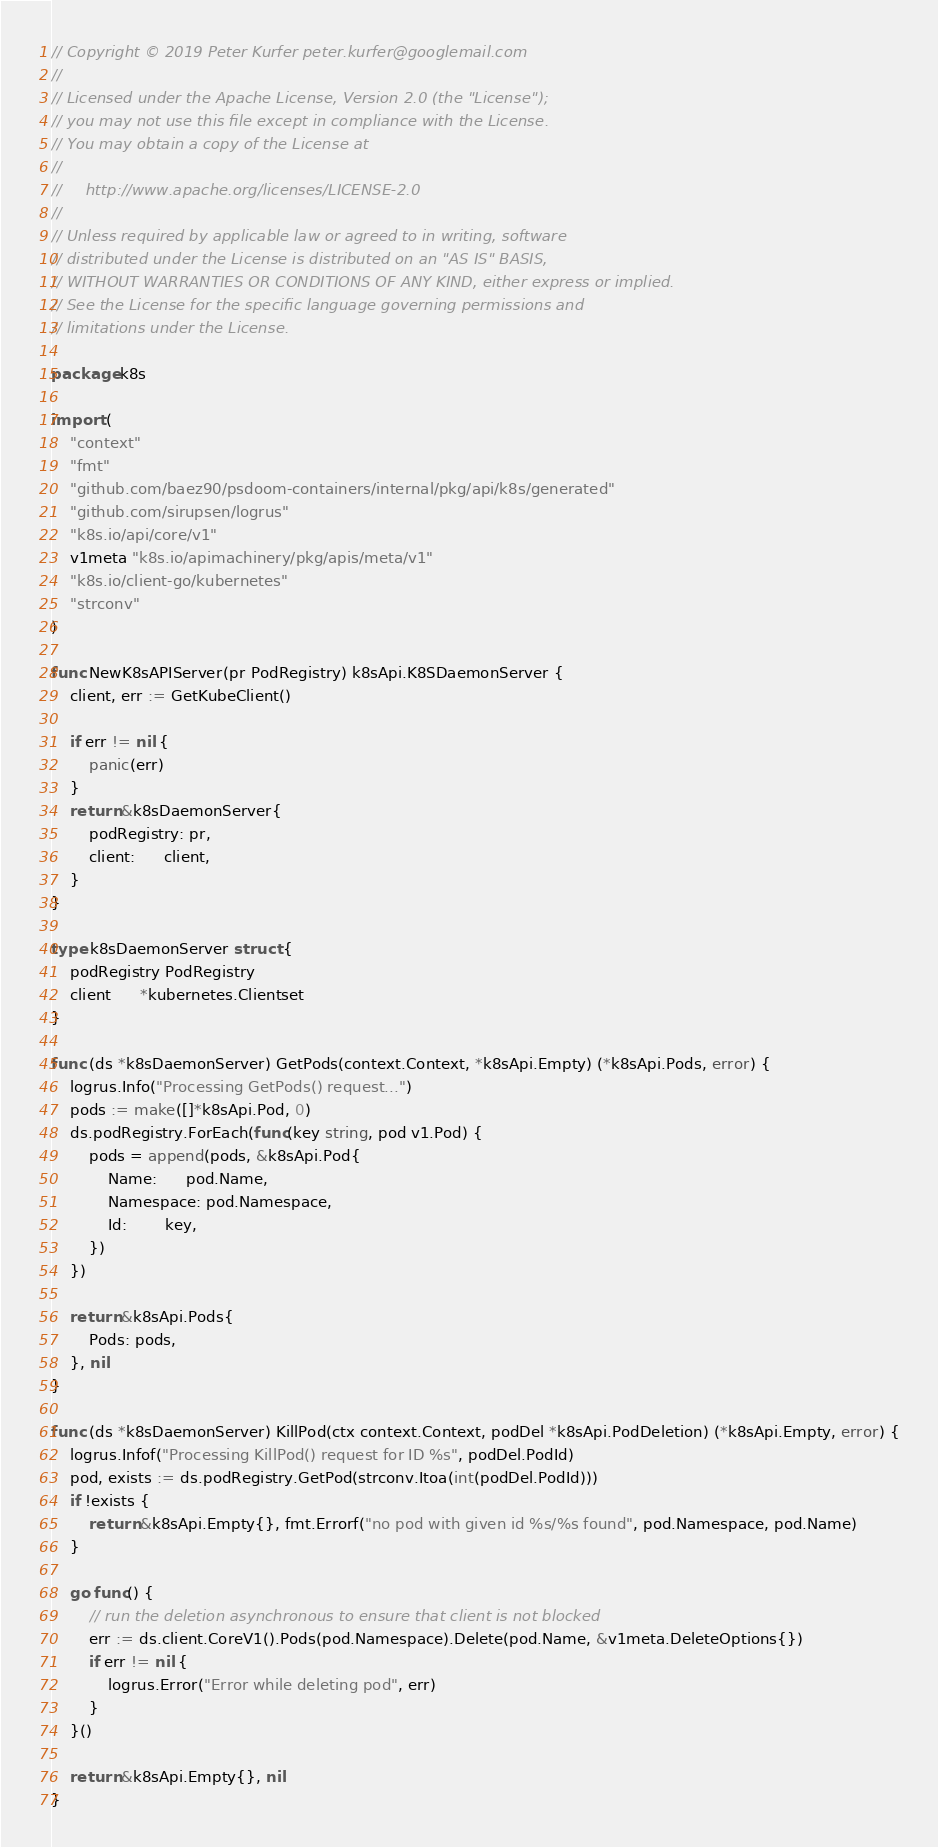Convert code to text. <code><loc_0><loc_0><loc_500><loc_500><_Go_>// Copyright © 2019 Peter Kurfer peter.kurfer@googlemail.com
//
// Licensed under the Apache License, Version 2.0 (the "License");
// you may not use this file except in compliance with the License.
// You may obtain a copy of the License at
//
//     http://www.apache.org/licenses/LICENSE-2.0
//
// Unless required by applicable law or agreed to in writing, software
// distributed under the License is distributed on an "AS IS" BASIS,
// WITHOUT WARRANTIES OR CONDITIONS OF ANY KIND, either express or implied.
// See the License for the specific language governing permissions and
// limitations under the License.

package k8s

import (
	"context"
	"fmt"
	"github.com/baez90/psdoom-containers/internal/pkg/api/k8s/generated"
	"github.com/sirupsen/logrus"
	"k8s.io/api/core/v1"
	v1meta "k8s.io/apimachinery/pkg/apis/meta/v1"
	"k8s.io/client-go/kubernetes"
	"strconv"
)

func NewK8sAPIServer(pr PodRegistry) k8sApi.K8SDaemonServer {
	client, err := GetKubeClient()

	if err != nil {
		panic(err)
	}
	return &k8sDaemonServer{
		podRegistry: pr,
		client:      client,
	}
}

type k8sDaemonServer struct {
	podRegistry PodRegistry
	client      *kubernetes.Clientset
}

func (ds *k8sDaemonServer) GetPods(context.Context, *k8sApi.Empty) (*k8sApi.Pods, error) {
	logrus.Info("Processing GetPods() request...")
	pods := make([]*k8sApi.Pod, 0)
	ds.podRegistry.ForEach(func(key string, pod v1.Pod) {
		pods = append(pods, &k8sApi.Pod{
			Name:      pod.Name,
			Namespace: pod.Namespace,
			Id:        key,
		})
	})

	return &k8sApi.Pods{
		Pods: pods,
	}, nil
}

func (ds *k8sDaemonServer) KillPod(ctx context.Context, podDel *k8sApi.PodDeletion) (*k8sApi.Empty, error) {
	logrus.Infof("Processing KillPod() request for ID %s", podDel.PodId)
	pod, exists := ds.podRegistry.GetPod(strconv.Itoa(int(podDel.PodId)))
	if !exists {
		return &k8sApi.Empty{}, fmt.Errorf("no pod with given id %s/%s found", pod.Namespace, pod.Name)
	}

	go func() {
		// run the deletion asynchronous to ensure that client is not blocked
		err := ds.client.CoreV1().Pods(pod.Namespace).Delete(pod.Name, &v1meta.DeleteOptions{})
		if err != nil {
			logrus.Error("Error while deleting pod", err)
		}
	}()

	return &k8sApi.Empty{}, nil
}
</code> 